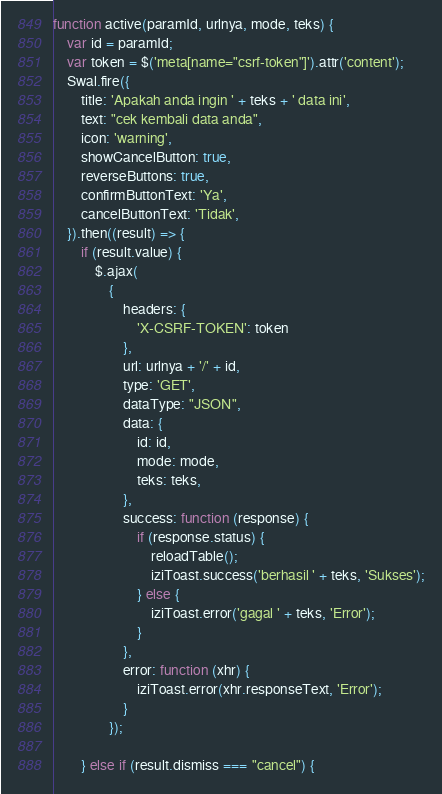Convert code to text. <code><loc_0><loc_0><loc_500><loc_500><_JavaScript_>function active(paramId, urlnya, mode, teks) {
    var id = paramId;
    var token = $('meta[name="csrf-token"]').attr('content');
    Swal.fire({
        title: 'Apakah anda ingin ' + teks + ' data ini',
        text: "cek kembali data anda",
        icon: 'warning',
        showCancelButton: true,
        reverseButtons: true,
        confirmButtonText: 'Ya',
        cancelButtonText: 'Tidak',
    }).then((result) => {
        if (result.value) {
            $.ajax(
                {
                    headers: {
                        'X-CSRF-TOKEN': token
                    },
                    url: urlnya + '/' + id,
                    type: 'GET',
                    dataType: "JSON",
                    data: {
                        id: id,
                        mode: mode,
                        teks: teks,
                    },
                    success: function (response) {
                        if (response.status) {
                            reloadTable();
                            iziToast.success('berhasil ' + teks, 'Sukses');
                        } else {
                            iziToast.error('gagal ' + teks, 'Error');
                        }
                    },
                    error: function (xhr) {
                        iziToast.error(xhr.responseText, 'Error');
                    }
                });

        } else if (result.dismiss === "cancel") {</code> 